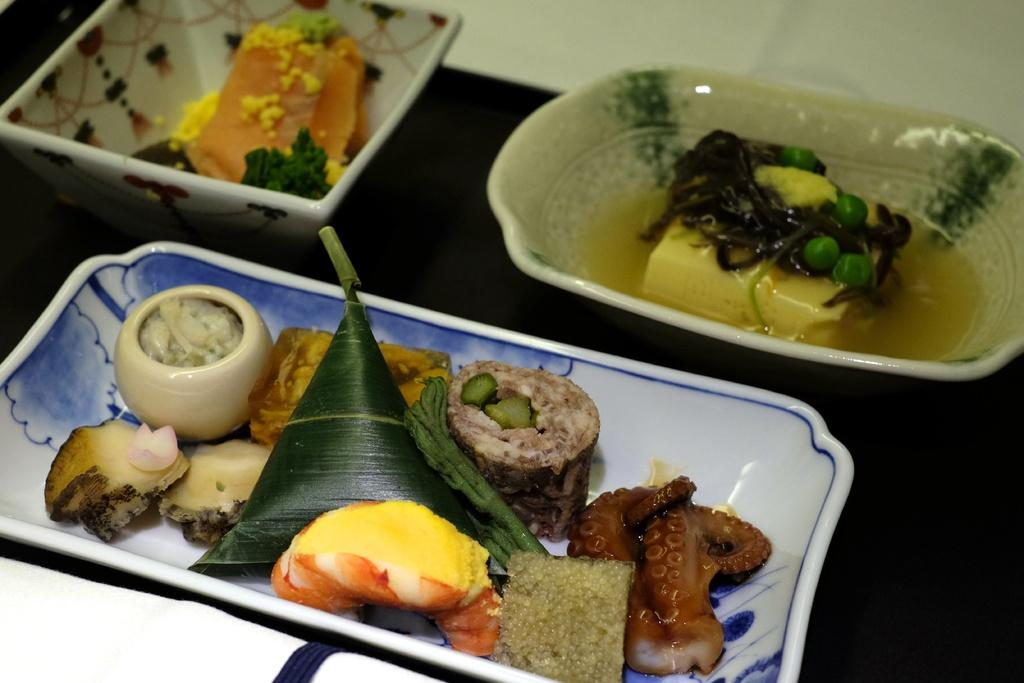How many bowls are visible in the image? There are three different bowls in the image. What is unique about each bowl? Each bowl contains a different type of food. What is the color of the surface on which the bowls are placed? The bowls are placed on a black surface. How many wings are visible on the bowls in the image? There are no wings visible on the bowls in the image. 